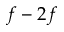<formula> <loc_0><loc_0><loc_500><loc_500>f - 2 f</formula> 